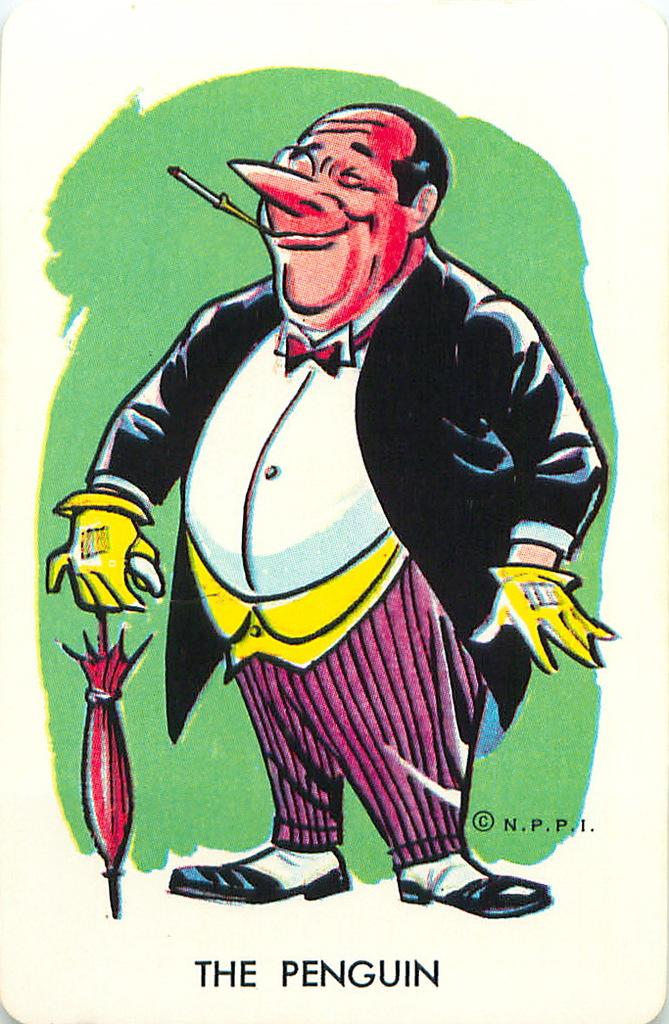What type of image is present in the picture? There is a cartoon image of a man in the picture. Is there any text associated with the image? Yes, there is text at the bottom of the picture. What is the taste of the cartoon man in the image? The cartoon man in the image does not have a taste, as it is a two-dimensional image and not a real person or object. 